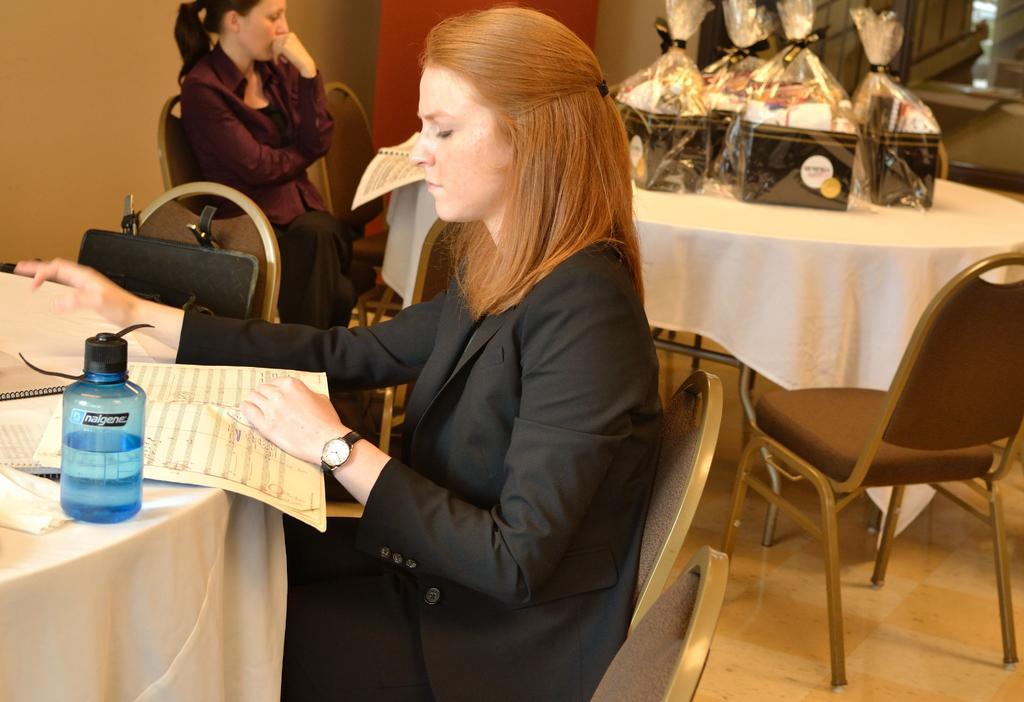Please provide a concise description of this image. In the image we can see there is a woman who is sitting on chair and on table there is paper and water bottle and the other side there is another woman sitting on chair and on table there are gifts which are packed in a plastic cover. 